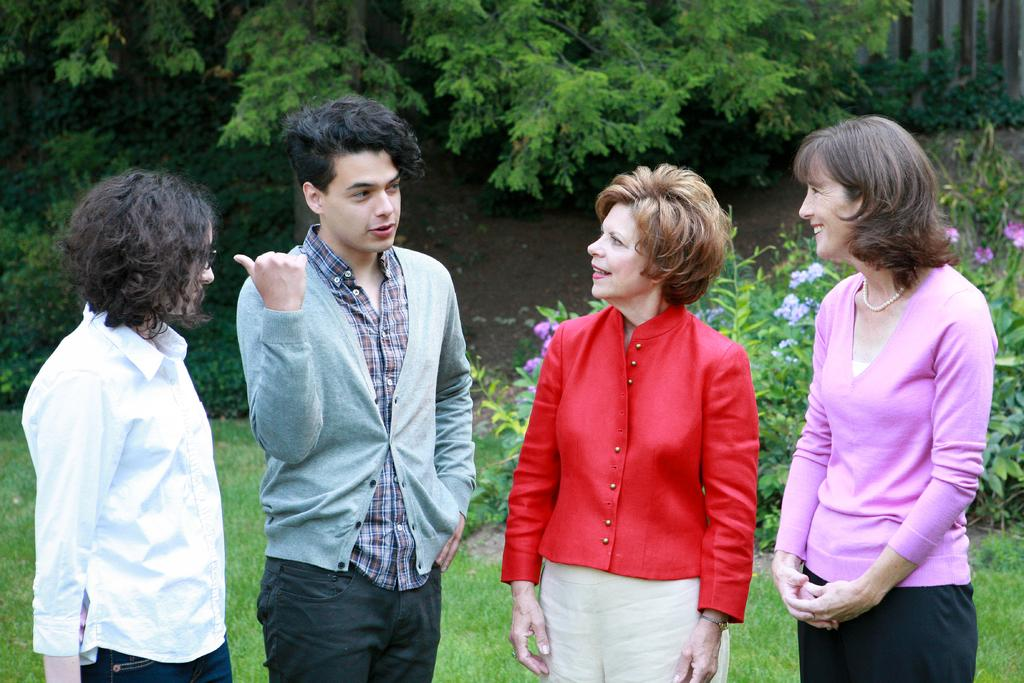How many people are present in the image? There are four persons standing in the image. What type of plants can be seen in the image? There are plants with flowers in the image. What is the ground surface like in the image? There is grass visible in the image. What can be seen in the background of the image? There are trees in the background of the image. What type of spoon is being used by the pigs in the image? There are no pigs or spoons present in the image. What organization is responsible for the arrangement of the plants in the image? There is no information about an organization responsible for the arrangement of the plants in the image. 